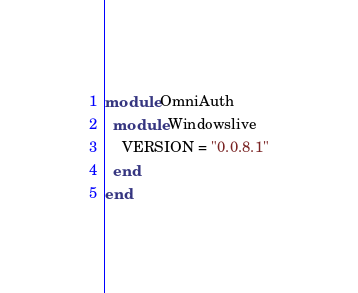<code> <loc_0><loc_0><loc_500><loc_500><_Ruby_>module OmniAuth
  module Windowslive
    VERSION = "0.0.8.1"
  end
end
</code> 